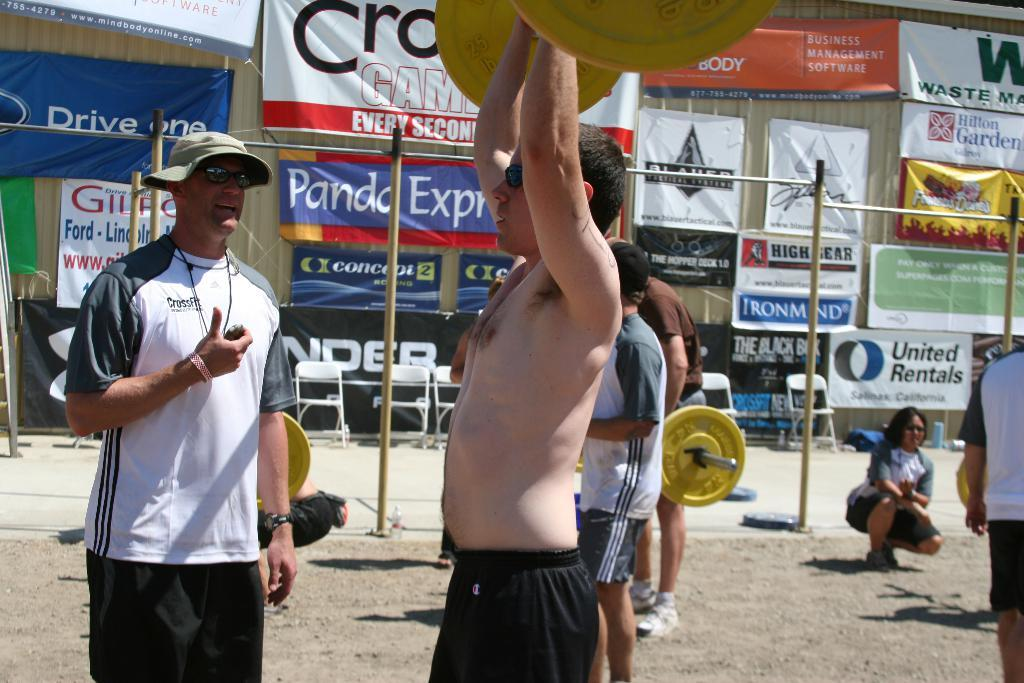What are the people in the image doing? The people in the image are holding heavy weights. Who is supervising or guiding the people in the image? There is a trainer present in the image. What can be seen in the background of the image? There are poles visible in the image. What type of furniture is present in the image? There are chairs in the image. What is hanging on the building in the image? There are banners hanging on a building in the image. How does the wind affect the people holding heavy weights in the image? There is no wind present in the image, so it does not affect the people holding heavy weights. 